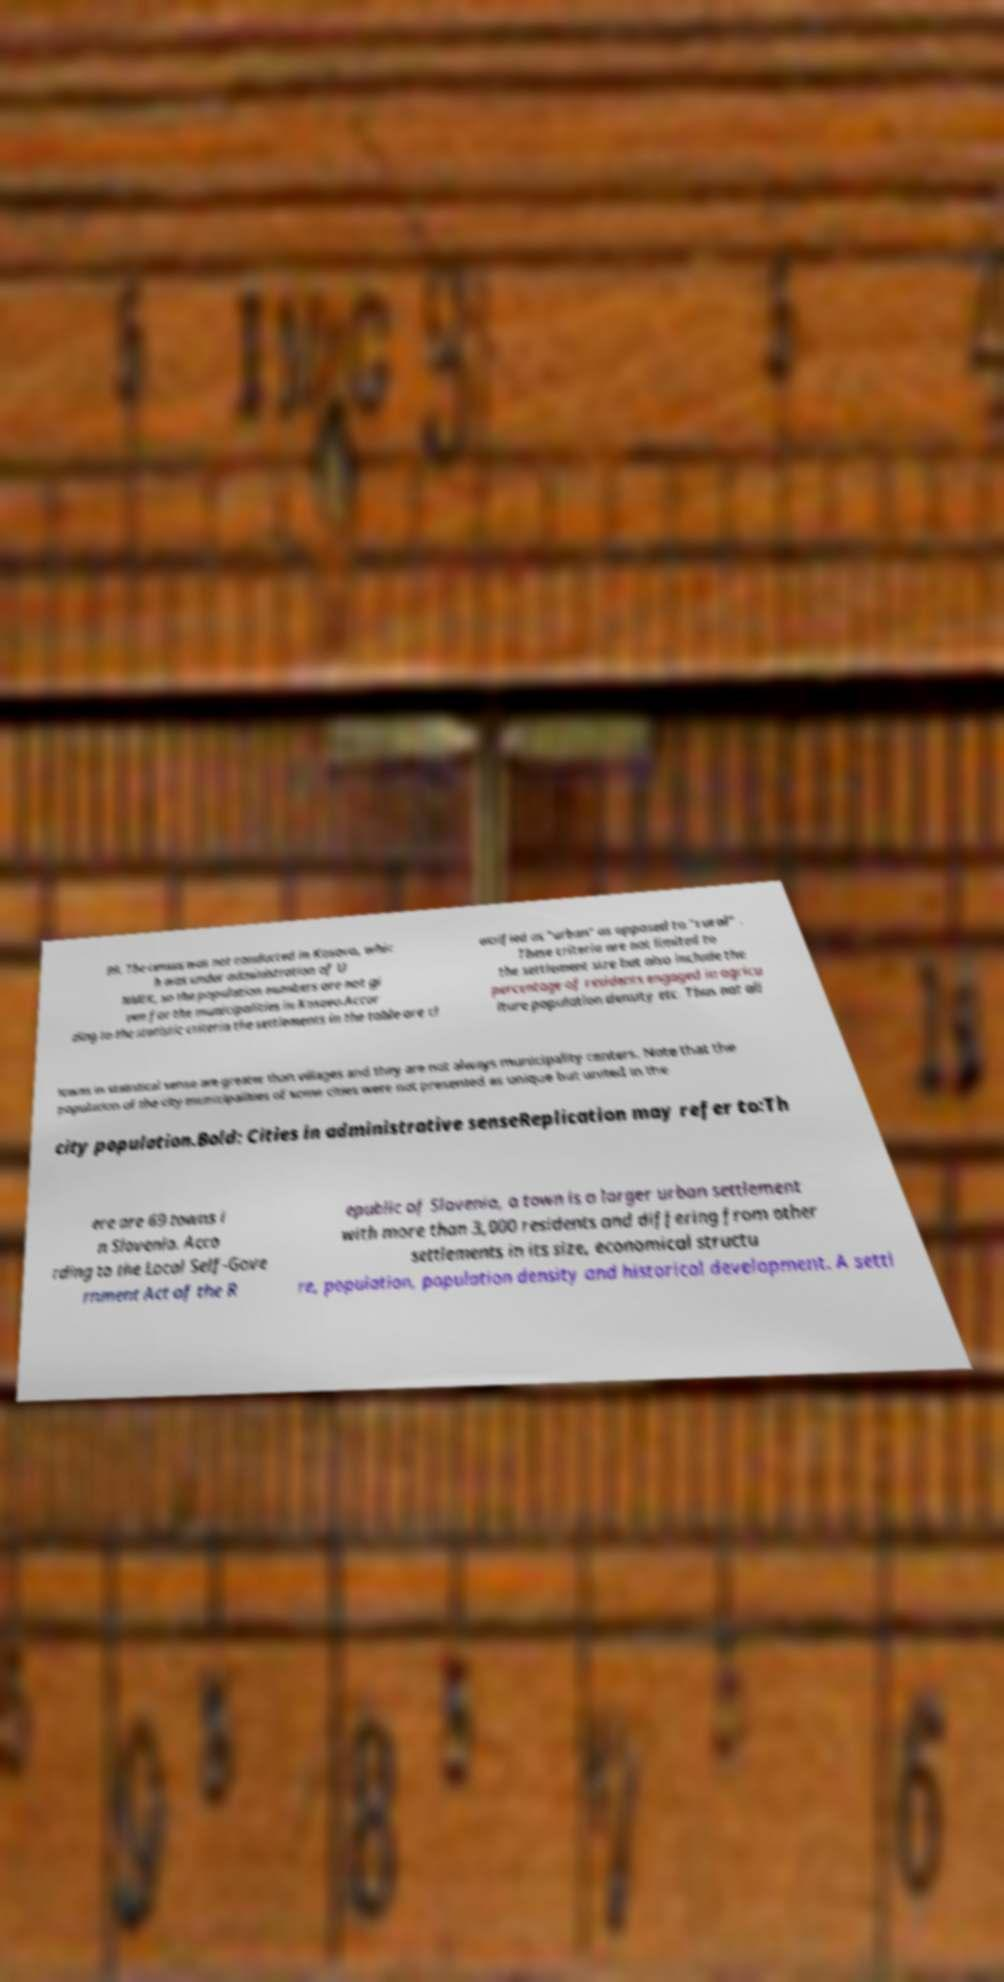There's text embedded in this image that I need extracted. Can you transcribe it verbatim? 99. The census was not conducted in Kosovo, whic h was under administration of U NMIK, so the population numbers are not gi ven for the municipalities in Kosovo.Accor ding to the statistic criteria the settlements in the table are cl assified as "urban" as opposed to "rural" . These criteria are not limited to the settlement size but also include the percentage of residents engaged in agricu lture population density etc. Thus not all towns in statistical sense are greater than villages and they are not always municipality centers. Note that the population of the city municipalities of some cities were not presented as unique but united in the city population.Bold: Cities in administrative senseReplication may refer to:Th ere are 69 towns i n Slovenia. Acco rding to the Local Self-Gove rnment Act of the R epublic of Slovenia, a town is a larger urban settlement with more than 3,000 residents and differing from other settlements in its size, economical structu re, population, population density and historical development. A settl 